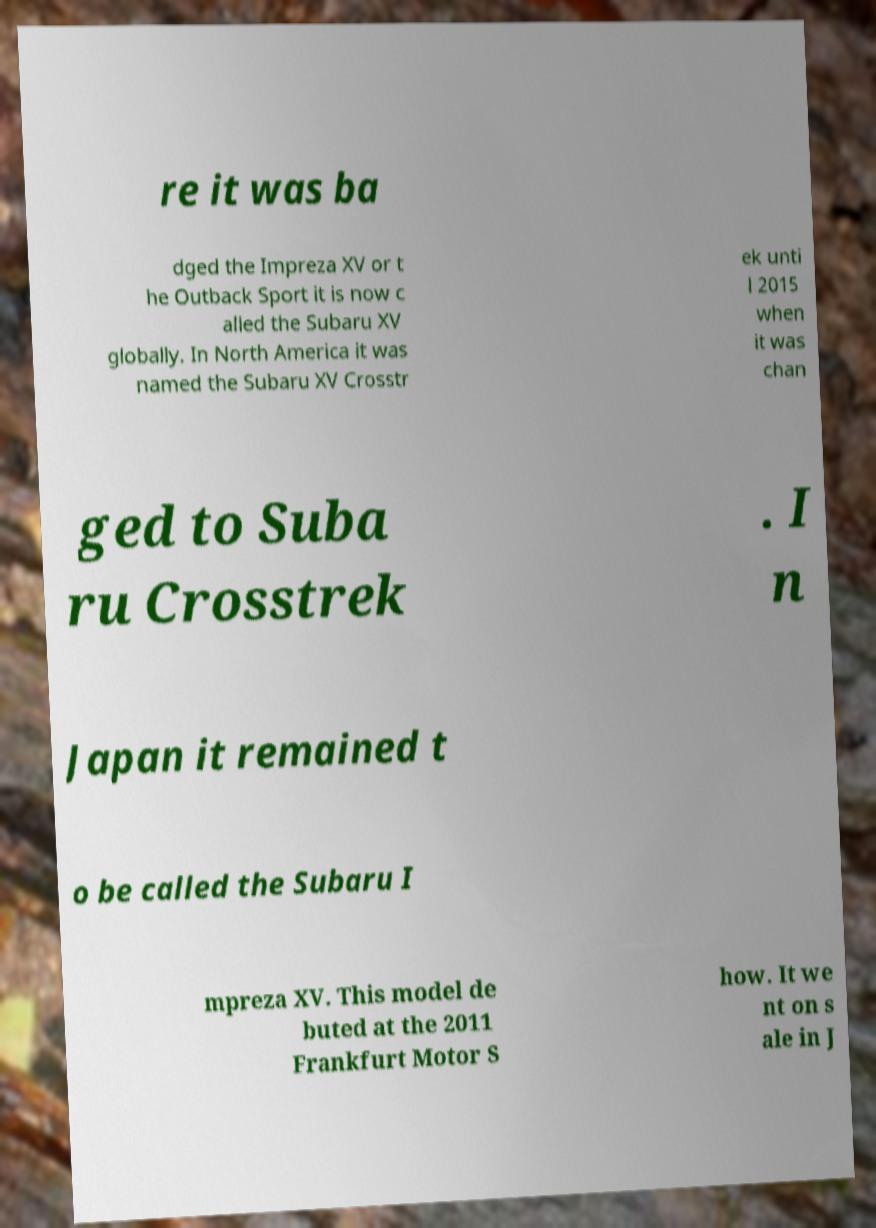For documentation purposes, I need the text within this image transcribed. Could you provide that? re it was ba dged the Impreza XV or t he Outback Sport it is now c alled the Subaru XV globally. In North America it was named the Subaru XV Crosstr ek unti l 2015 when it was chan ged to Suba ru Crosstrek . I n Japan it remained t o be called the Subaru I mpreza XV. This model de buted at the 2011 Frankfurt Motor S how. It we nt on s ale in J 